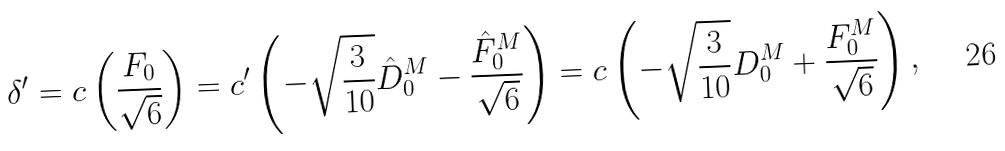<formula> <loc_0><loc_0><loc_500><loc_500>\delta ^ { \prime } = c \left ( \frac { F _ { 0 } } { \sqrt { 6 } } \right ) = c ^ { \prime } \left ( - \sqrt { \frac { 3 } { 1 0 } } \hat { D } ^ { M } _ { 0 } - \frac { \hat { F } ^ { M } _ { 0 } } { \sqrt { 6 } } \right ) = c \left ( - \sqrt { \frac { 3 } { 1 0 } } D ^ { M } _ { 0 } + \frac { F ^ { M } _ { 0 } } { \sqrt { 6 } } \right ) ,</formula> 